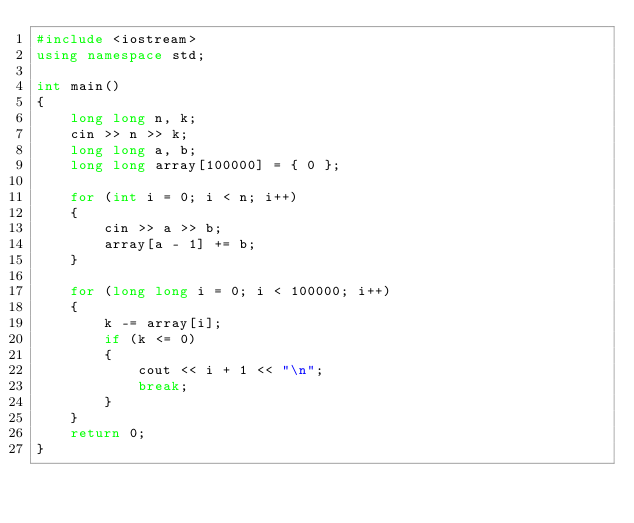Convert code to text. <code><loc_0><loc_0><loc_500><loc_500><_C++_>#include <iostream>
using namespace std;

int main()
{
	long long n, k;
	cin >> n >> k;
	long long a, b;
	long long array[100000] = { 0 };

	for (int i = 0; i < n; i++)
	{
		cin >> a >> b;
		array[a - 1] += b;
	}

	for (long long i = 0; i < 100000; i++)
	{
		k -= array[i];
		if (k <= 0)
		{
			cout << i + 1 << "\n";
			break;
		}
	}
	return 0;
}

</code> 